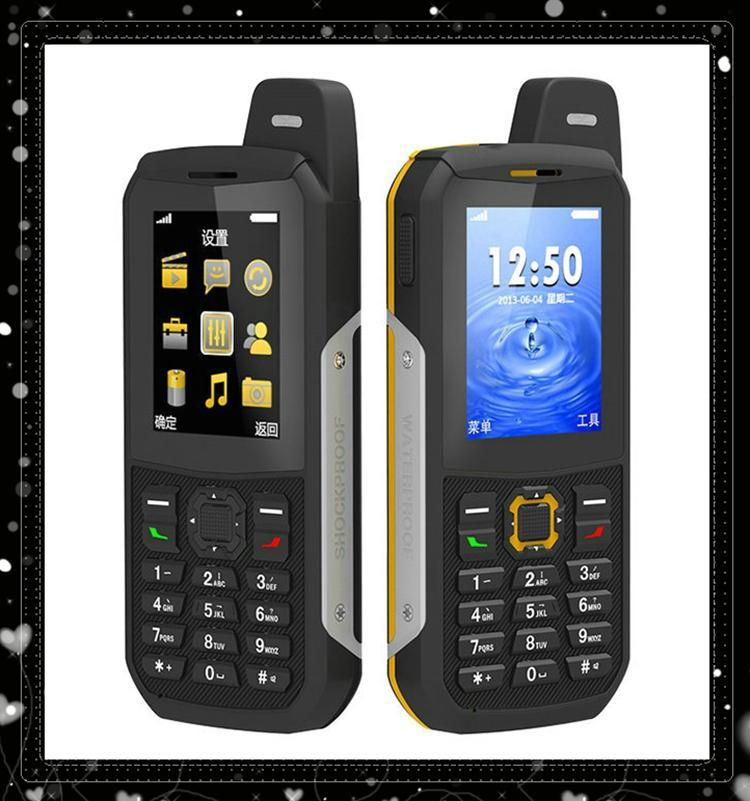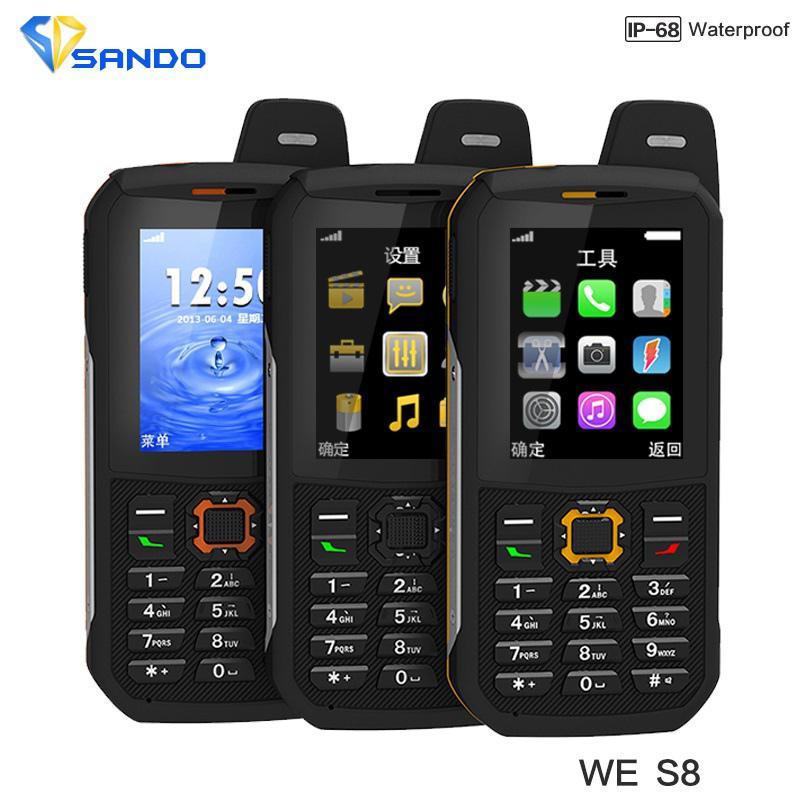The first image is the image on the left, the second image is the image on the right. Assess this claim about the two images: "One image contains just the front side of a phone and the other image shows both the front and back side of a phone.". Correct or not? Answer yes or no. No. The first image is the image on the left, the second image is the image on the right. Examine the images to the left and right. Is the description "There are two phones in one of the images and one phone in the other." accurate? Answer yes or no. No. 